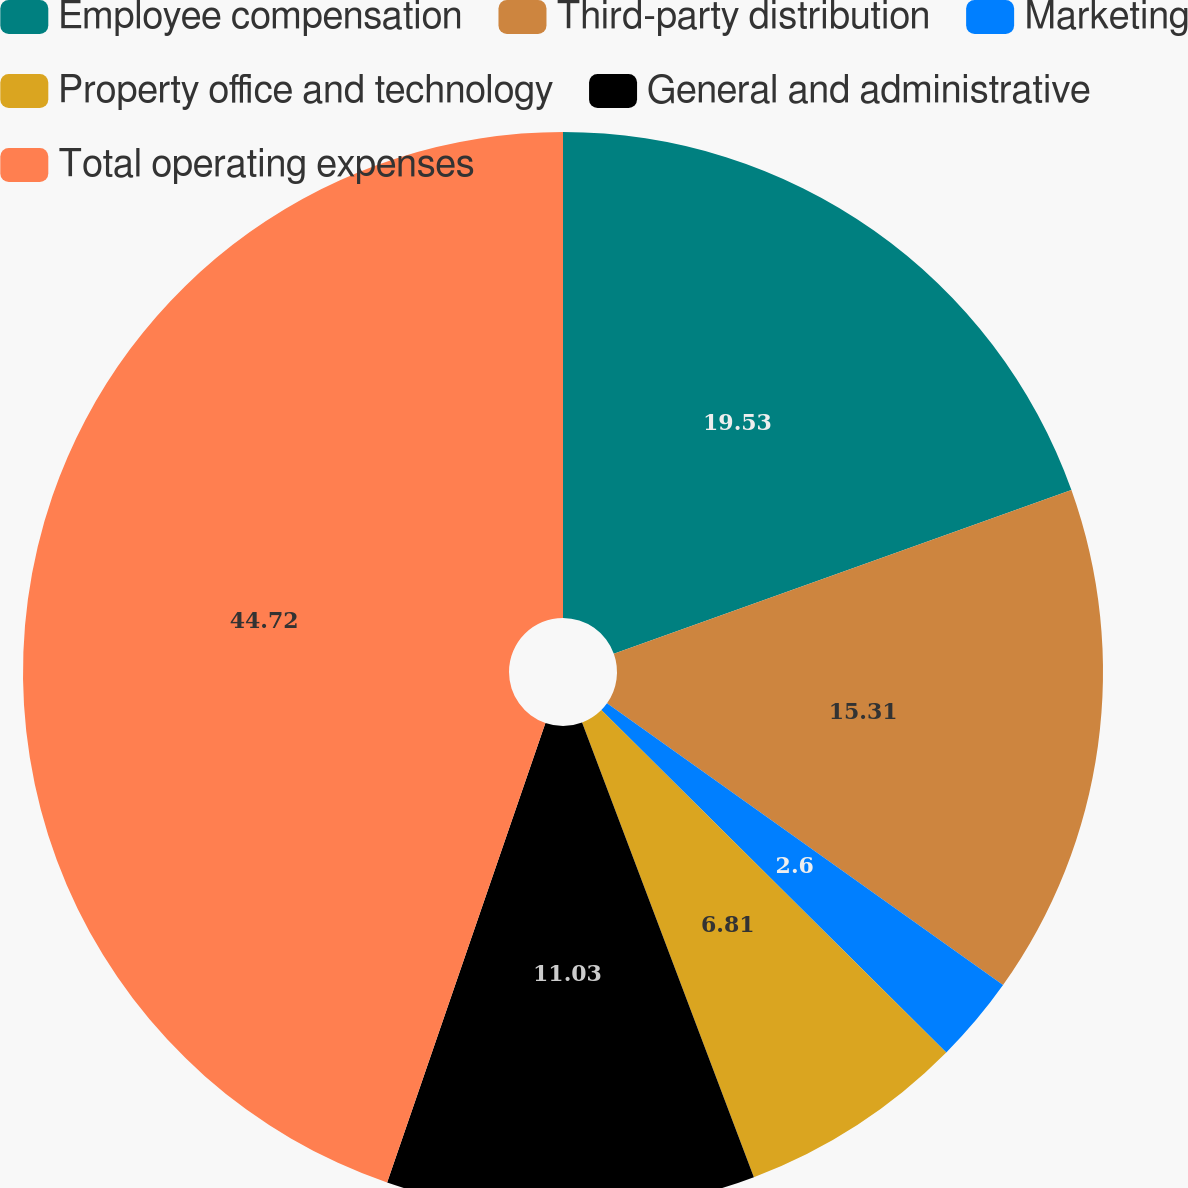Convert chart. <chart><loc_0><loc_0><loc_500><loc_500><pie_chart><fcel>Employee compensation<fcel>Third-party distribution<fcel>Marketing<fcel>Property office and technology<fcel>General and administrative<fcel>Total operating expenses<nl><fcel>19.53%<fcel>15.31%<fcel>2.6%<fcel>6.81%<fcel>11.03%<fcel>44.72%<nl></chart> 